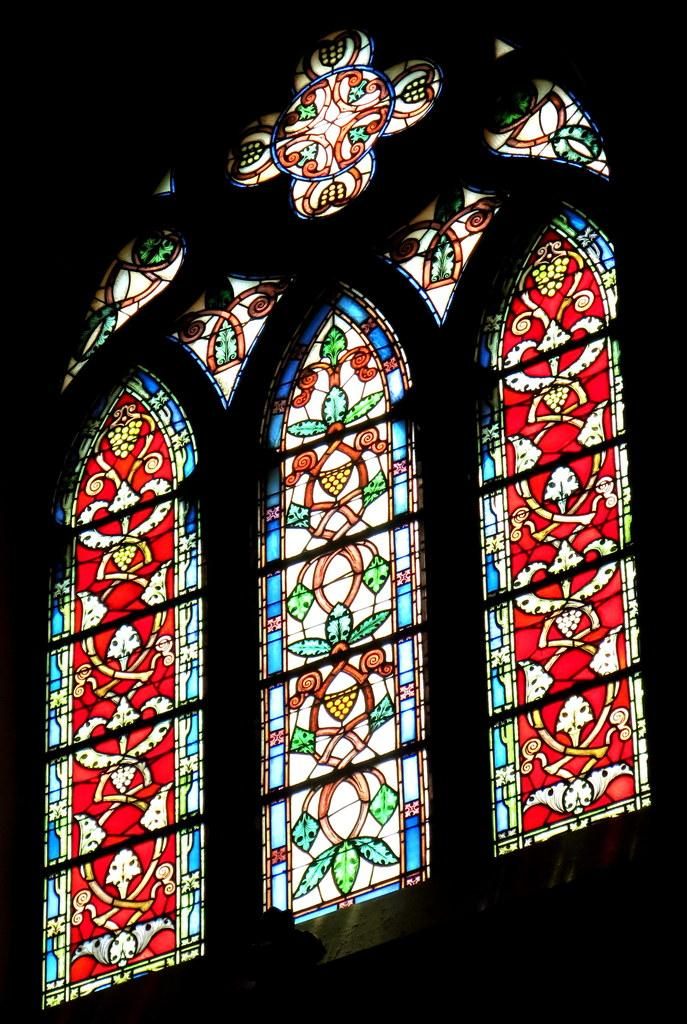What type of glass is depicted in the image? There are stained glasses in the image. Can you describe the background of the image? The background of the image is dark. What type of sheet is covering the car in the image? There is no car or sheet present in the image; it only features stained glasses and a dark background. 